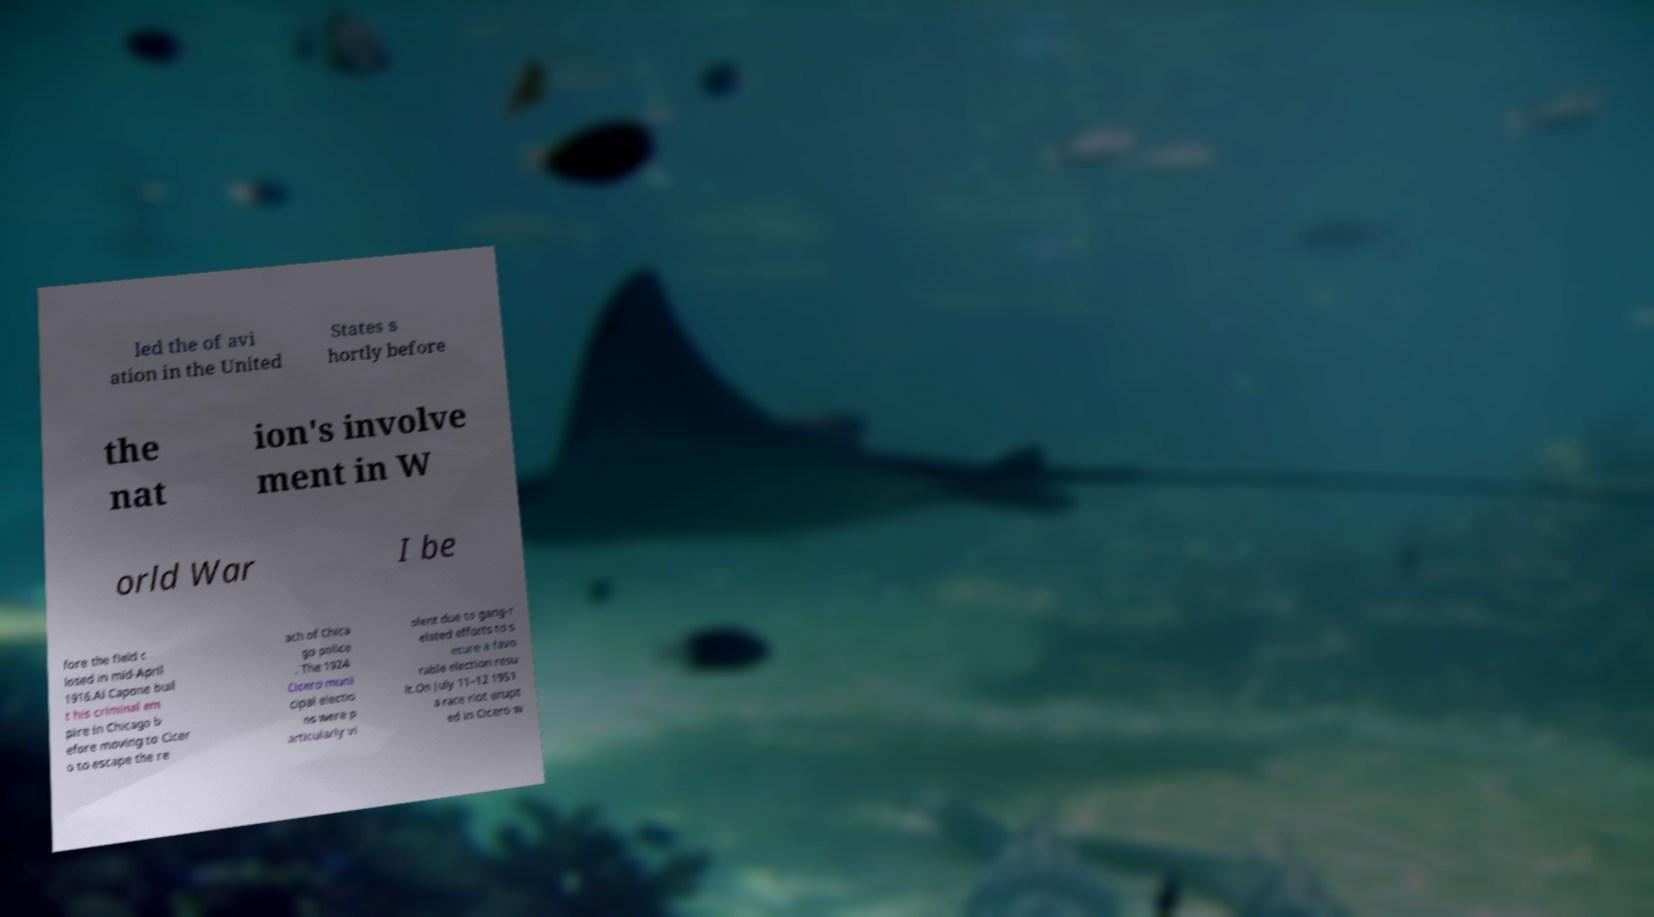Can you read and provide the text displayed in the image?This photo seems to have some interesting text. Can you extract and type it out for me? led the of avi ation in the United States s hortly before the nat ion's involve ment in W orld War I be fore the field c losed in mid-April 1916.Al Capone buil t his criminal em pire in Chicago b efore moving to Cicer o to escape the re ach of Chica go police . The 1924 Cicero muni cipal electio ns were p articularly vi olent due to gang-r elated efforts to s ecure a favo rable election resu lt.On July 11–12 1951 a race riot erupt ed in Cicero w 